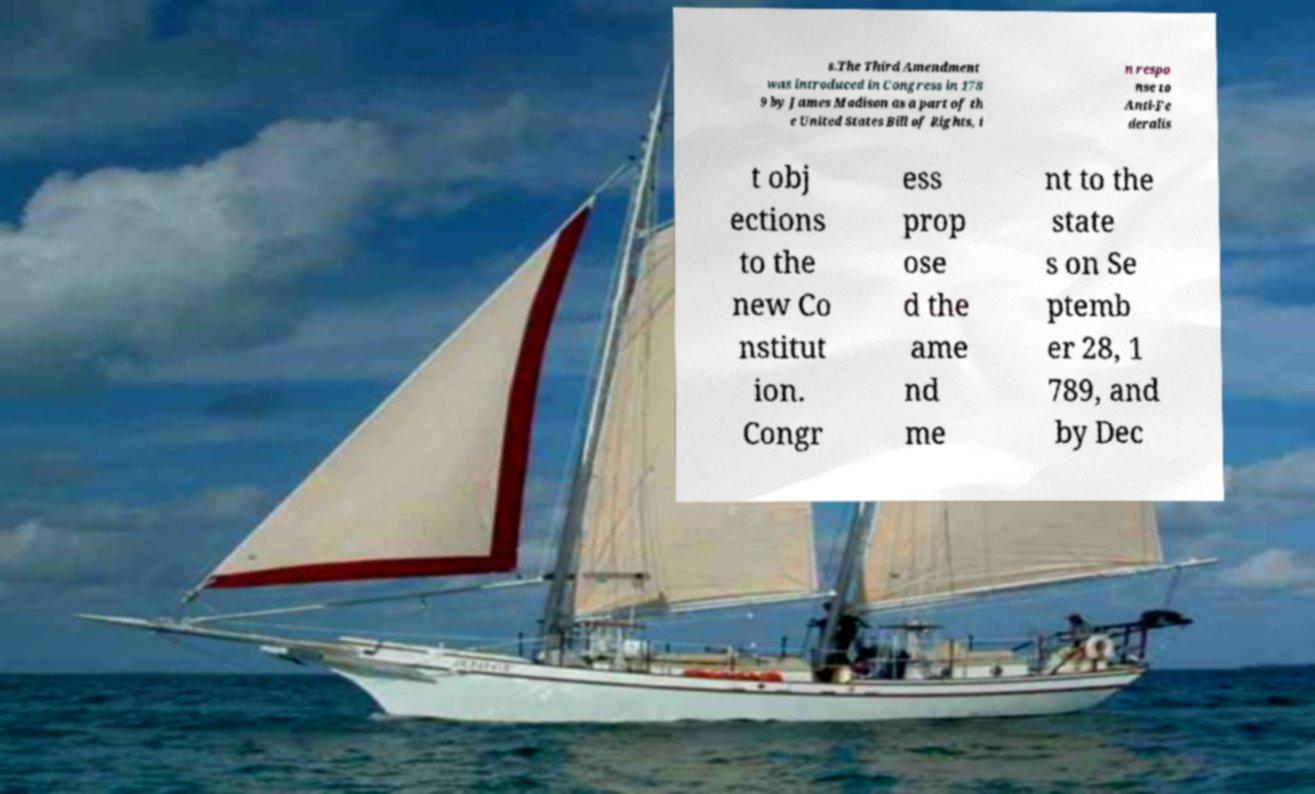Can you read and provide the text displayed in the image?This photo seems to have some interesting text. Can you extract and type it out for me? s.The Third Amendment was introduced in Congress in 178 9 by James Madison as a part of th e United States Bill of Rights, i n respo nse to Anti-Fe deralis t obj ections to the new Co nstitut ion. Congr ess prop ose d the ame nd me nt to the state s on Se ptemb er 28, 1 789, and by Dec 